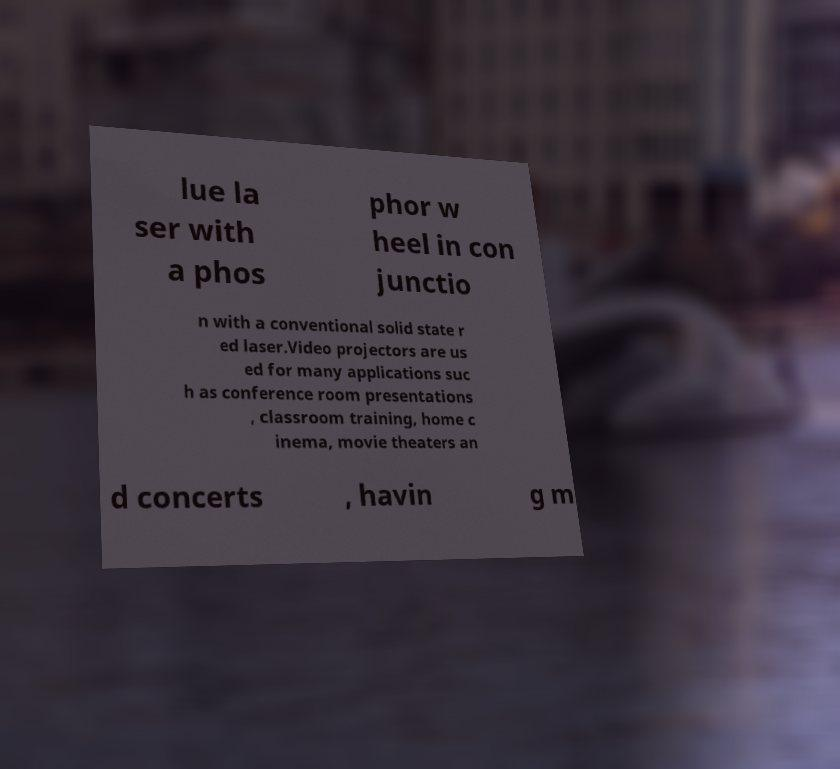There's text embedded in this image that I need extracted. Can you transcribe it verbatim? lue la ser with a phos phor w heel in con junctio n with a conventional solid state r ed laser.Video projectors are us ed for many applications suc h as conference room presentations , classroom training, home c inema, movie theaters an d concerts , havin g m 